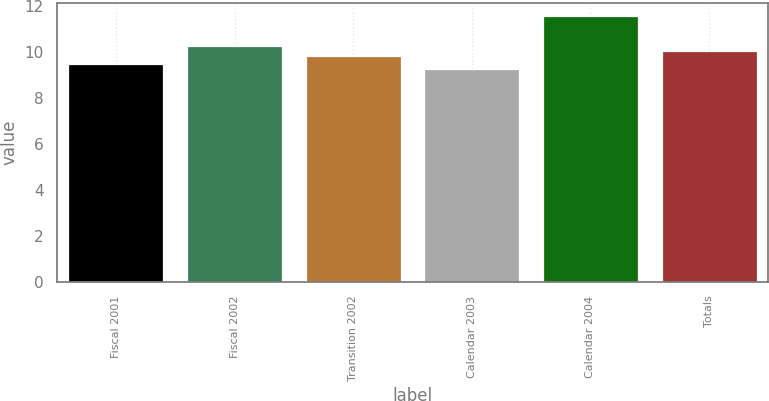Convert chart. <chart><loc_0><loc_0><loc_500><loc_500><bar_chart><fcel>Fiscal 2001<fcel>Fiscal 2002<fcel>Transition 2002<fcel>Calendar 2003<fcel>Calendar 2004<fcel>Totals<nl><fcel>9.5<fcel>10.27<fcel>9.81<fcel>9.26<fcel>11.55<fcel>10.04<nl></chart> 